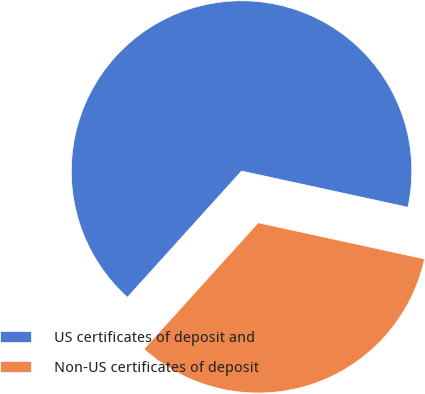Convert chart. <chart><loc_0><loc_0><loc_500><loc_500><pie_chart><fcel>US certificates of deposit and<fcel>Non-US certificates of deposit<nl><fcel>66.71%<fcel>33.29%<nl></chart> 